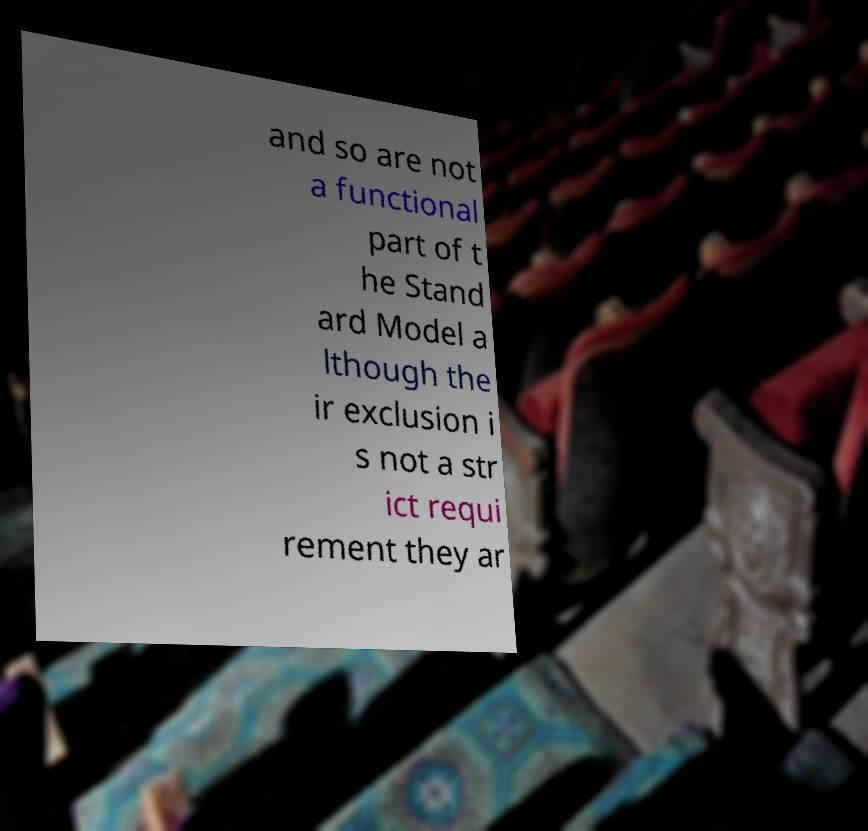Please identify and transcribe the text found in this image. and so are not a functional part of t he Stand ard Model a lthough the ir exclusion i s not a str ict requi rement they ar 